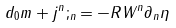Convert formula to latex. <formula><loc_0><loc_0><loc_500><loc_500>d _ { 0 } m + j ^ { n } ; _ { n } = - R W ^ { n } \partial _ { n } \eta</formula> 